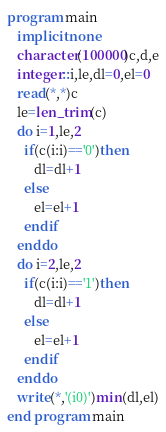Convert code to text. <code><loc_0><loc_0><loc_500><loc_500><_FORTRAN_>program main
   implicit none
   character(100000)c,d,e
   integer::i,le,dl=0,el=0
   read(*,*)c
   le=len_trim(c)
   do i=1,le,2
     if(c(i:i)=='0')then
        dl=dl+1
     else
        el=el+1
     endif
   enddo
   do i=2,le,2
     if(c(i:i)=='1')then
        dl=dl+1
     else
        el=el+1
     endif     
   enddo
   write(*,'(i0)')min(dl,el)
end program main
</code> 